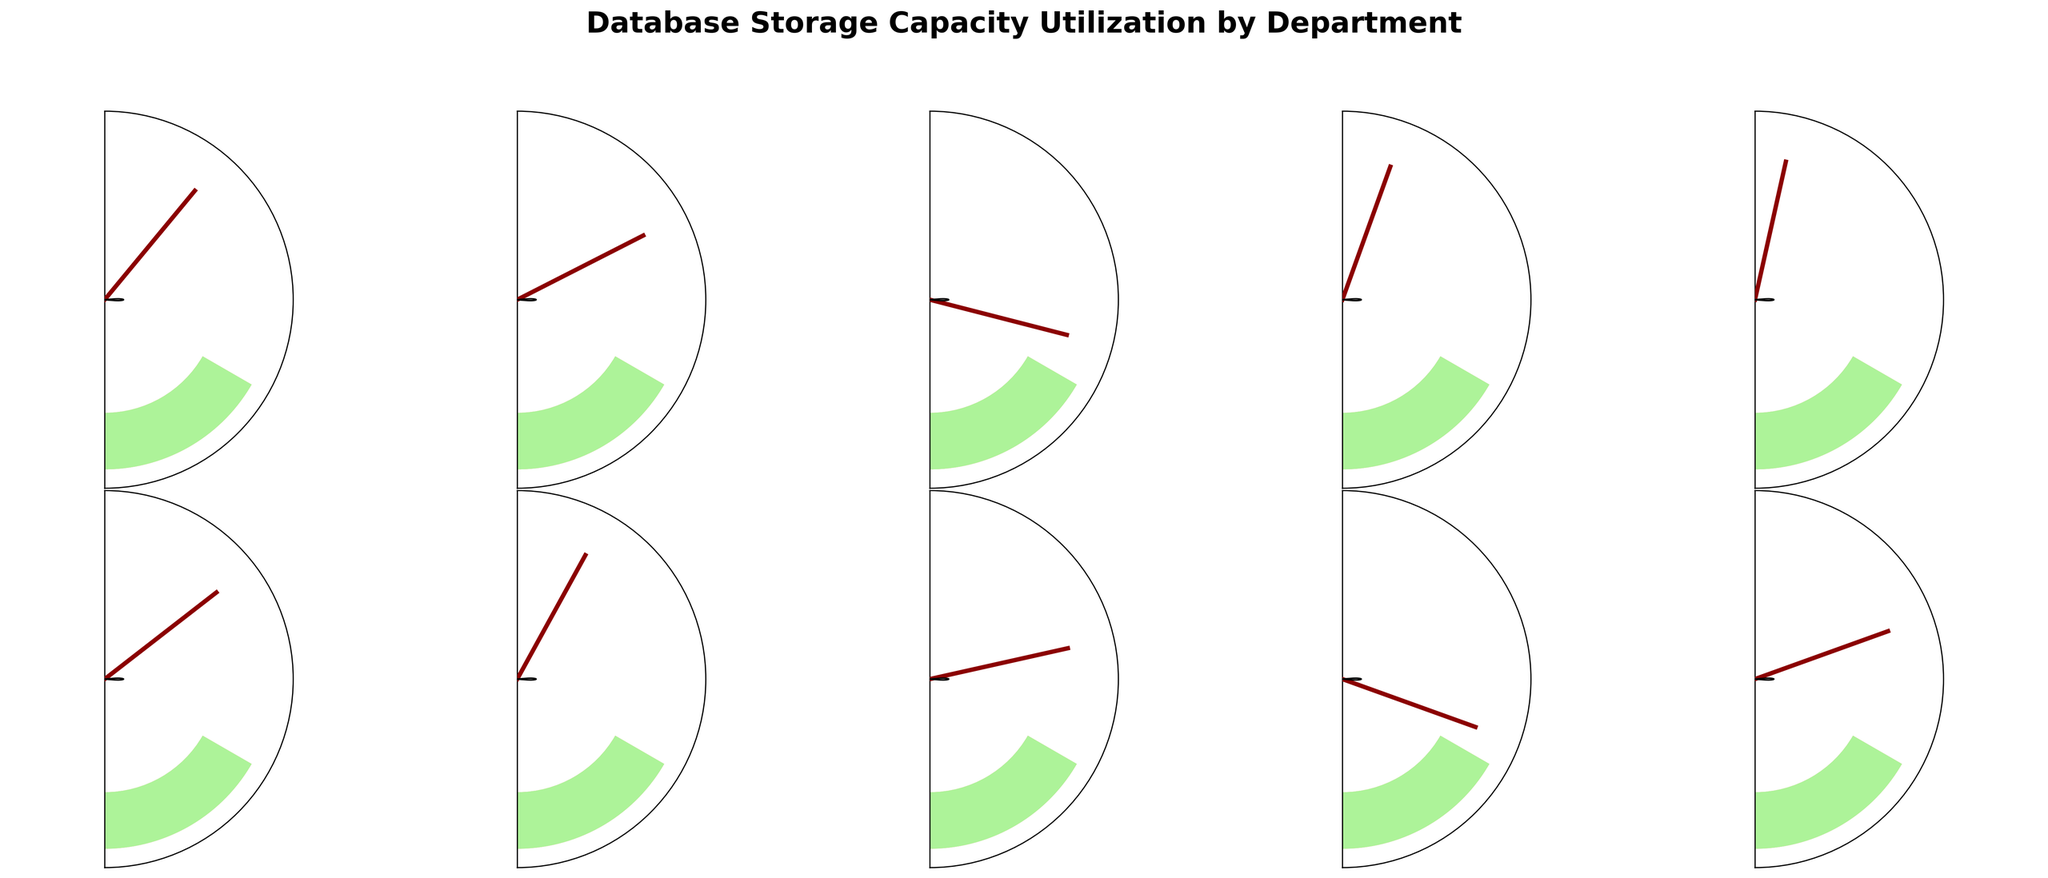Which department has the highest storage capacity utilization? The gauge chart shows the storage capacity utilization for each department. Among them, the IT department has the highest percentage, which is 93%.
Answer: IT What is the approximate average utilization percentage for all departments? To find the average, sum all utilization percentages (78 + 65 + 42 + 89 + 93 + 71 + 84 + 57 + 39 + 61 = 679) and divide by the number of departments (10). The average is 679/10 = 67.9%.
Answer: 67.9% How many departments have a storage utilization percentage below 50%? By examining the chart, the departments with storage utilization percentages below 50% are Human Resources (42%) and Legal (39%). Therefore, there are 2 such departments.
Answer: 2 Which departments have a utilization percentage within the range of 60% to 80%? The departments that fall within the 60% to 80% range are Sales (78%), Marketing (65%), Customer Support (71%), and Administration (61%).
Answer: Sales, Marketing, Customer Support, Administration What is the difference between the highest and lowest storage capacity utilization percentages? To find the difference, subtract the lowest percentage (Legal, 39%) from the highest percentage (IT, 93%). The difference is 93 - 39 = 54%.
Answer: 54% Which department shows storage utilization closest to the average utilization percentage? The average utilization percentage is 67.9%. Among the departments, Marketing (65%) and Administration (61%) are the closest. Comparing the differences, Marketing is closer with a difference of 2.9%.
Answer: Marketing Are there more departments above or below the 65% utilization threshold? Count the number of departments above and below 65%. Above 65%: Sales, Finance, IT, Customer Support, Research and Development (5 departments). Below 65%: Marketing, Human Resources, Operations, Legal, Administration (5 departments). The numbers are equal.
Answer: Equal Which department has exactly mid-level utilization among all shown? The mid-level percentage in a sorted list is around the 5th or 6th value. Sorted: Legal (39%), Human Resources (42%), Operations (57%), Administration (61%), Marketing (65%), Customer Support (71%), Sales (78%), Research and Development (84%), Finance (89%), IT (93%). Mid-level is Customer Support (71%).
Answer: Customer Support What percentage range is not occupied by any department? From the chart observation and provided values, there are no percentages within the range of 94% to 96% occupied by any department.
Answer: 94% to 96% 